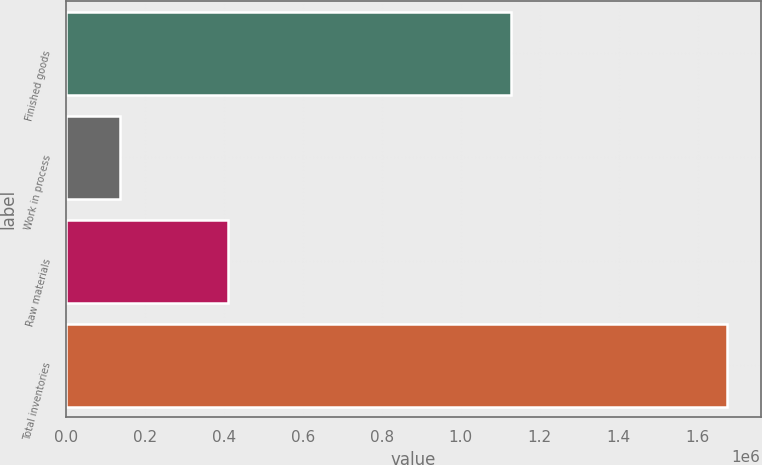<chart> <loc_0><loc_0><loc_500><loc_500><bar_chart><fcel>Finished goods<fcel>Work in process<fcel>Raw materials<fcel>Total inventories<nl><fcel>1.12757e+06<fcel>137310<fcel>410868<fcel>1.67575e+06<nl></chart> 